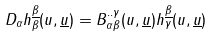<formula> <loc_0><loc_0><loc_500><loc_500>D _ { \alpha } h ^ { \underline { \beta } } _ { \beta } ( u , { \underline { u } } ) = B ^ { { . . } { \gamma } } _ { { \alpha } { \beta } } ( u , { \underline { u } } ) h ^ { \underline { \beta } } _ { \gamma } ( u , { \underline { u } } )</formula> 